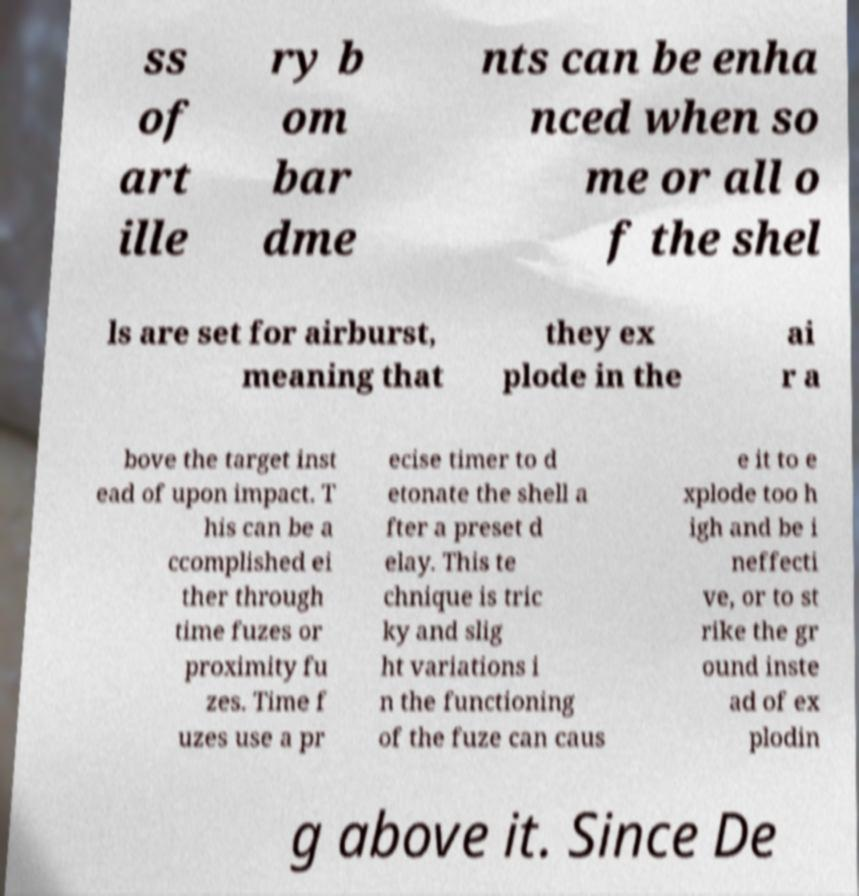There's text embedded in this image that I need extracted. Can you transcribe it verbatim? ss of art ille ry b om bar dme nts can be enha nced when so me or all o f the shel ls are set for airburst, meaning that they ex plode in the ai r a bove the target inst ead of upon impact. T his can be a ccomplished ei ther through time fuzes or proximity fu zes. Time f uzes use a pr ecise timer to d etonate the shell a fter a preset d elay. This te chnique is tric ky and slig ht variations i n the functioning of the fuze can caus e it to e xplode too h igh and be i neffecti ve, or to st rike the gr ound inste ad of ex plodin g above it. Since De 